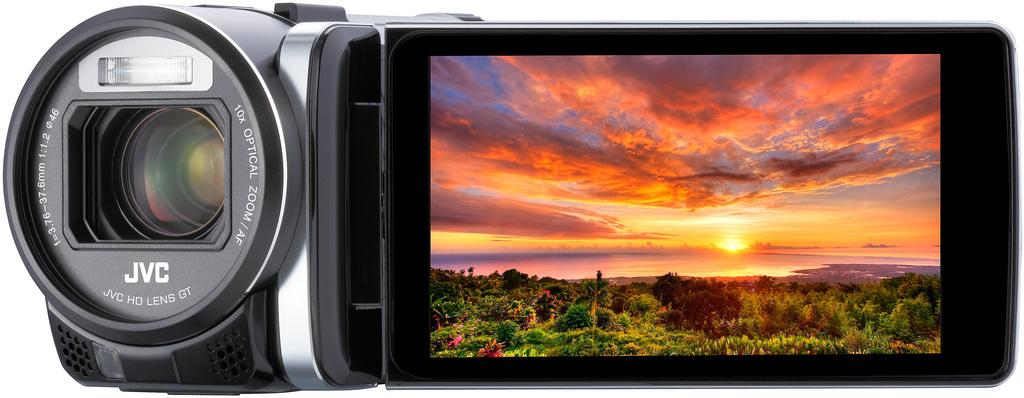What object is the main subject of the picture? There is a camera in the picture. What is displayed on the camera's screen? The camera's screen displays trees. What natural elements can be seen in the image? Water and the sky are visible in the image. What is the condition of the sky in the image? The sky is visible with clouds and the sun. What additional information is present on the camera? There is text on the camera. What type of doctor is examining the ship in the image? There is no doctor or ship present in the image; it features a camera with a screen displaying trees and text. Is the camera being used for spying purposes in the image? There is no indication in the image that the camera is being used for spying purposes. 